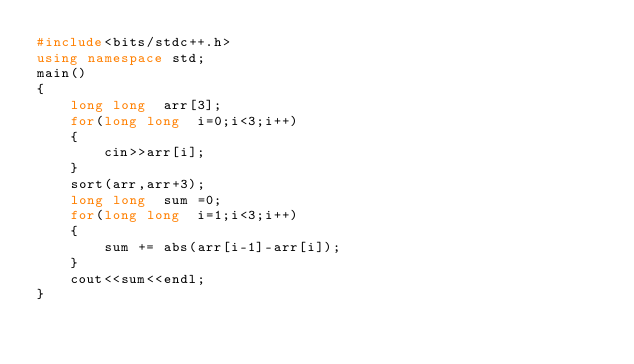Convert code to text. <code><loc_0><loc_0><loc_500><loc_500><_C++_>#include<bits/stdc++.h>
using namespace std;
main()
{
	long long  arr[3];
	for(long long  i=0;i<3;i++)
	{
		cin>>arr[i];
	}
	sort(arr,arr+3);
	long long  sum =0;
	for(long long  i=1;i<3;i++)
	{
		sum += abs(arr[i-1]-arr[i]);
	}
	cout<<sum<<endl;
}</code> 